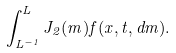<formula> <loc_0><loc_0><loc_500><loc_500>\int ^ { L } _ { L ^ { - 1 } } J _ { 2 } ( m ) f ( x , t , d m ) .</formula> 